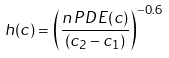Convert formula to latex. <formula><loc_0><loc_0><loc_500><loc_500>h ( c ) = \left ( \frac { n \, P D E ( c ) } { ( c _ { 2 } - c _ { 1 } ) } \right ) ^ { - 0 . 6 }</formula> 